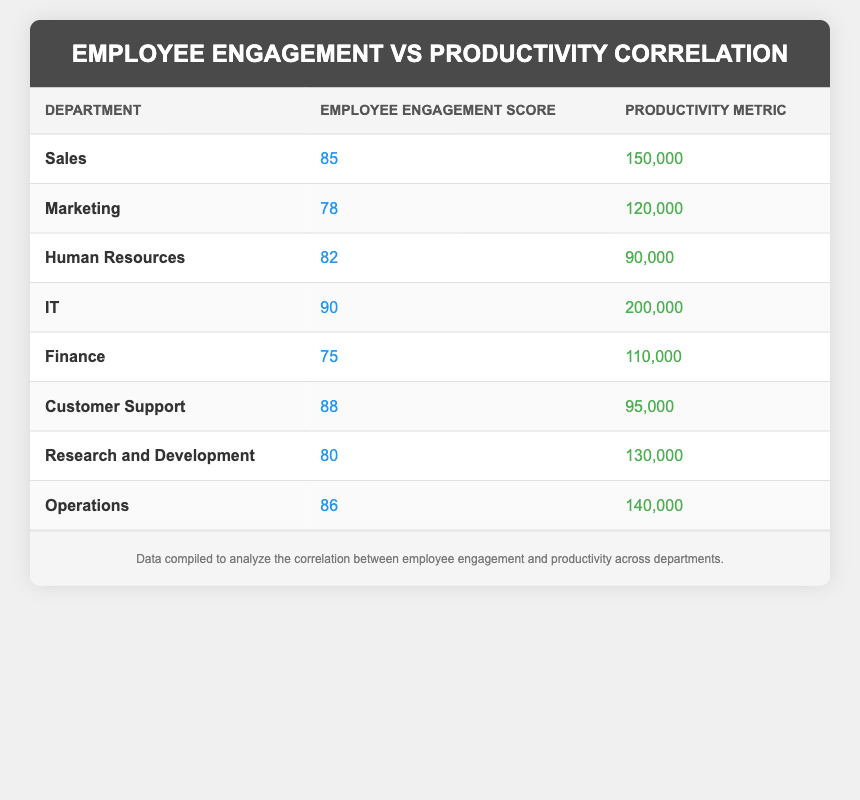What is the employee engagement score for the IT department? The table lists the employee engagement score for each department. Looking at the IT row, the score is clearly indicated as 90.
Answer: 90 Which department has the highest productivity metric? By inspecting the productivity metric values in the table, the IT department shows the highest figure at 200,000, which is greater than all other entries.
Answer: IT What is the employee engagement score for the Marketing department? The table provides the engagement score for the Marketing department, which can be directly found in its row, and the score is 78.
Answer: 78 Is the employee engagement score for Human Resources greater than 80? The engagement score for Human Resources is listed as 82. Since 82 is greater than 80, the answer is yes.
Answer: Yes What is the average employee engagement score for all departments? To calculate the average, sum all the engagement scores: (85 + 78 + 82 + 90 + 75 + 88 + 80 + 86) = 674. There are 8 departments, so the average is 674 divided by 8, which equals 84.25.
Answer: 84.25 Which department has both an employee engagement score above 85 and a productivity metric under 100,000? From the table, I first identify departments with engagement scores above 85, which include Sales, IT, Customer Support, and Operations. Then, I check their productivity metrics. Only Customer Support has a productivity metric of 95,000, which is under 100,000.
Answer: Customer Support What is the difference in productivity metrics between the highest and lowest departments? The highest productivity metric is from IT at 200,000 and the lowest is from Human Resources at 90,000. The difference is calculated by subtracting the lowest from the highest: 200,000 - 90,000 = 110,000.
Answer: 110,000 Are there more departments with an engagement score above 80 or below 80? I count the departments with engagement scores above 80: Sales, IT, Customer Support, Operations, and Human Resources, totaling 5. Those below 80 are Marketing and Finance, totaling 2. Since 5 is greater than 2, the answer is yes.
Answer: Yes 